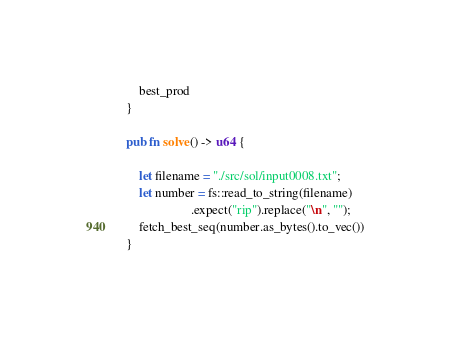Convert code to text. <code><loc_0><loc_0><loc_500><loc_500><_Rust_>    best_prod
}

pub fn solve() -> u64 {
    
    let filename = "./src/sol/input0008.txt";
    let number = fs::read_to_string(filename)
                    .expect("rip").replace("\n", "");
    fetch_best_seq(number.as_bytes().to_vec())
}
</code> 